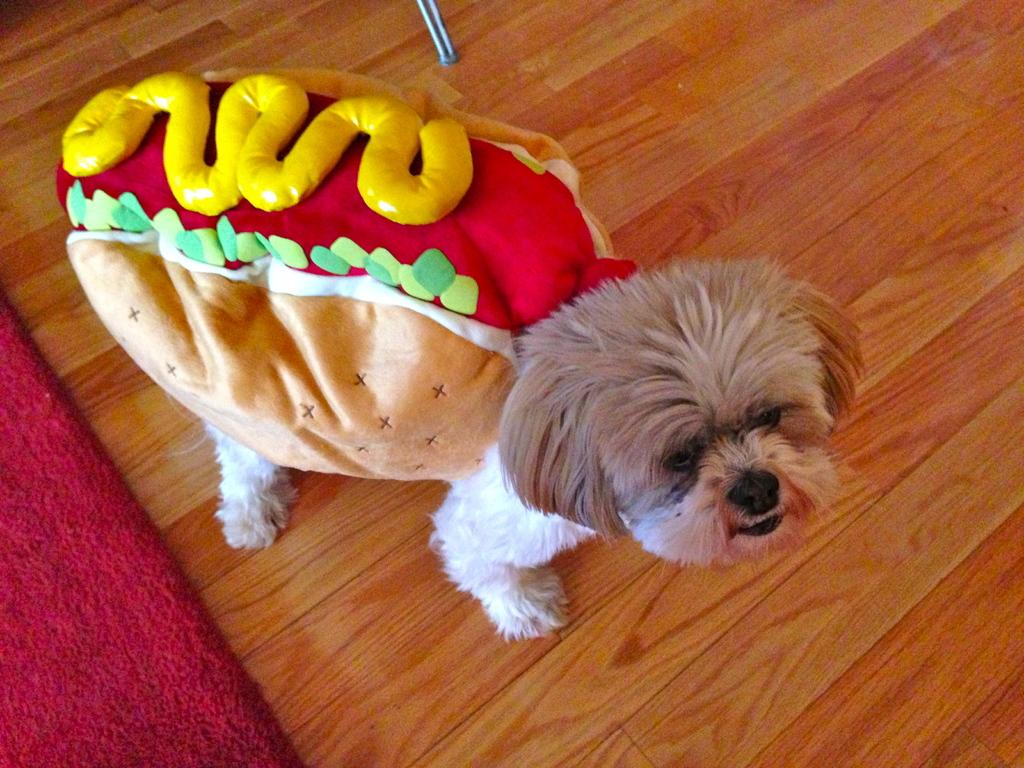What is the main subject of the image? There is a dog at the center of the image. What type of flooring is visible at the bottom of the image? There is a wooden floor at the bottom of the image. What color is the carpet on the left side of the image? There is a red color carpet on the left side of the image. How many bottles of water are visible on the wooden floor in the image? There are no bottles of water visible in the image; it only features a dog, a wooden floor, and a red carpet. 